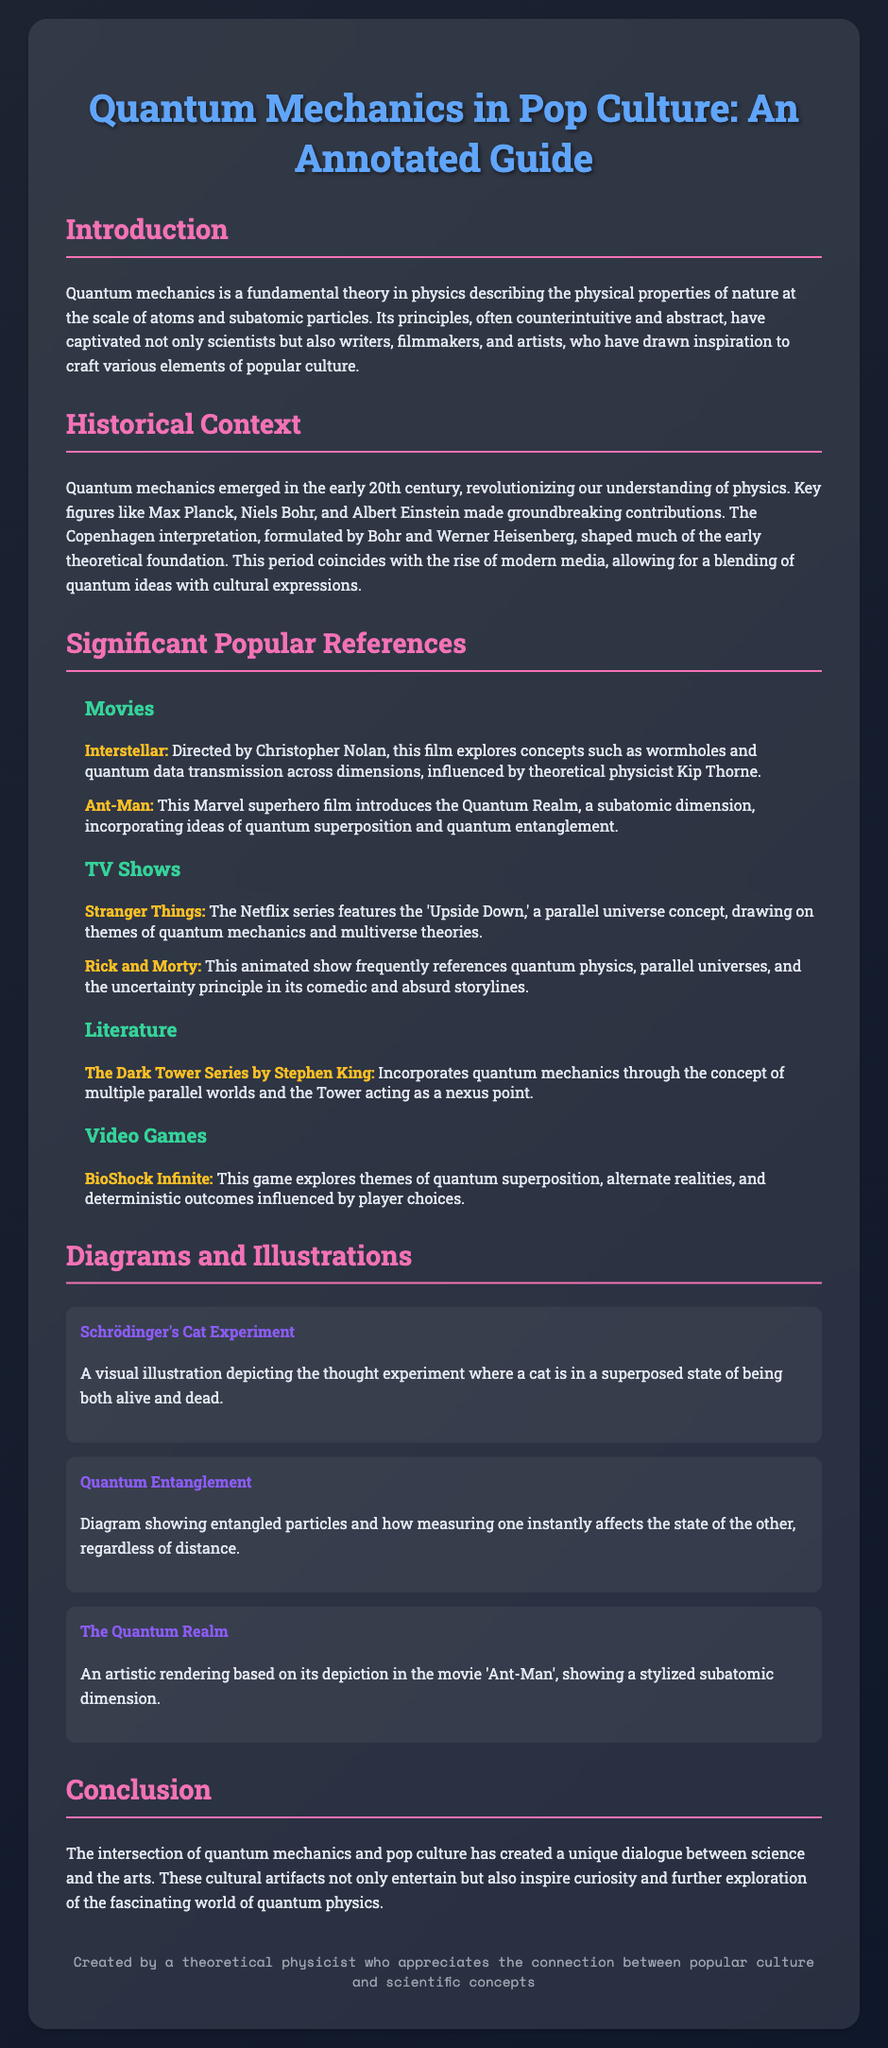What is the title of the document? The title is the main heading of the document described within the HTML structure.
Answer: Quantum Mechanics in Pop Culture: An Annotated Guide Who directed the movie "Interstellar"? The document mentions the director in the context of discussing significant popular references in movies.
Answer: Christopher Nolan What phenomenon does "Ant-Man" introduce? The document identifies the specific quantum concept related to "Ant-Man" under the movies section.
Answer: Quantum Realm Which series features the 'Upside Down'? The document lists significant references, including the one that features the 'Upside Down' as a parallel universe.
Answer: Stranger Things What concept is illustrated by Schrödinger's Cat? This is a key thought experiment mentioned in the document that pertains to quantum mechanics.
Answer: Superposition Which author incorporated quantum mechanics into "The Dark Tower Series"? The document provides this information in the literature section, addressing authorial contributions to popular culture.
Answer: Stephen King What key scientific theory emerged in the early 20th century? The historical context section outlines this revolutionary concept central to the document's theme.
Answer: Quantum Mechanics What diagram illustrates entangled particles? The title of a specific diagram in the illustrations section asks about its content focus.
Answer: Quantum Entanglement 